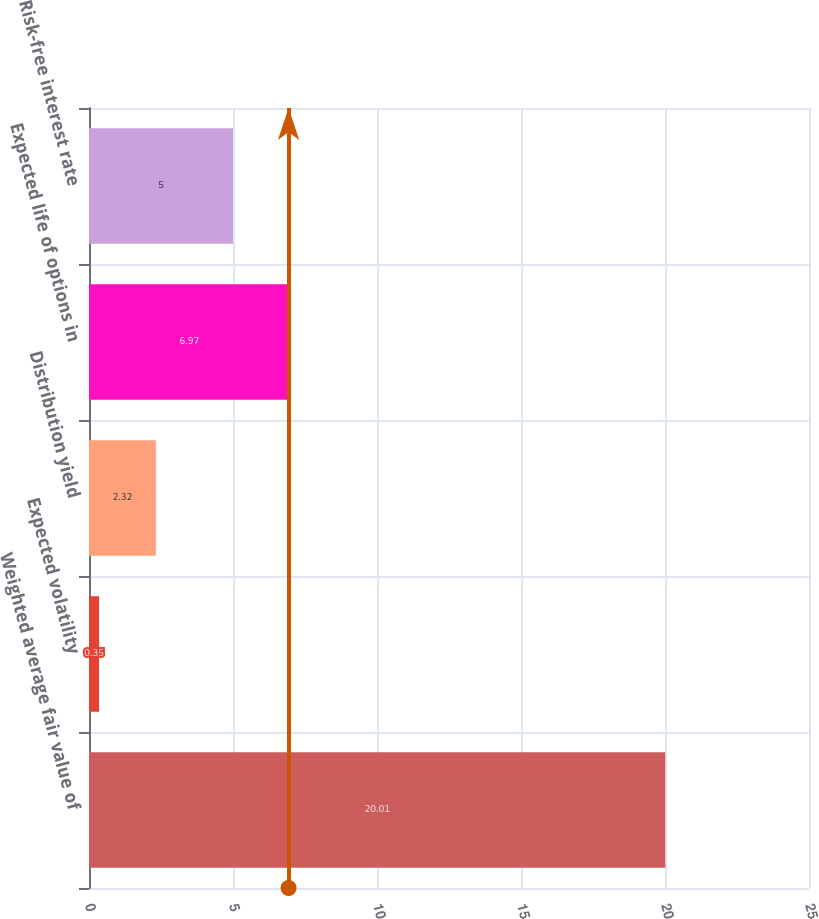<chart> <loc_0><loc_0><loc_500><loc_500><bar_chart><fcel>Weighted average fair value of<fcel>Expected volatility<fcel>Distribution yield<fcel>Expected life of options in<fcel>Risk-free interest rate<nl><fcel>20.01<fcel>0.35<fcel>2.32<fcel>6.97<fcel>5<nl></chart> 